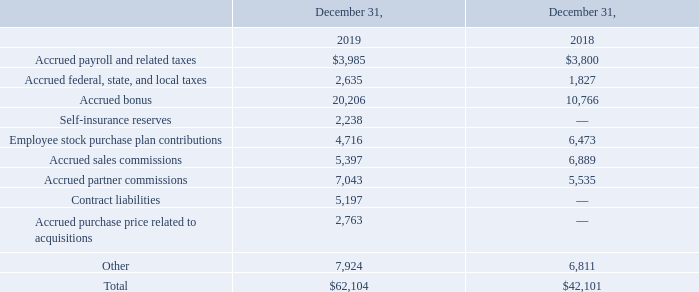Accrued expenses consisted of the following (in thousands):
Contract liabilities represent amounts that are collected in advance of the satisfaction of performance obligations under the new revenue recognition standard. See Recently Adopted Accounting Standards in Note 2 and Contract Liabilities in Note 6.
What does contract liabilities refer to? Amounts that are collected in advance of the satisfaction of performance obligations under the new revenue recognition standard. Where are the relevant parts of the annual report pertaining to contract liabilities? Recently adopted accounting standards in note 2 and contract liabilities in note 6. What are the total accrued expenses in 2018 and 2019 respectively?
Answer scale should be: thousand. 42,101, 62,104. What is the percentage change in total accrued expenses between 2018 and 2019?
Answer scale should be: percent. (62,104 - 42,101)/42,101 
Answer: 47.51. What is the total accrued bonus in 2018 and 2019?
Answer scale should be: thousand. 10,766 + 20,206 
Answer: 30972. What is the value of the 2018 accrued bonus as a percentage of the 2018 total accrued expenses?
Answer scale should be: percent. 10,766/42,101 
Answer: 25.57. 